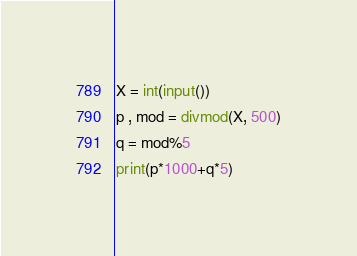<code> <loc_0><loc_0><loc_500><loc_500><_Python_>X = int(input())
p , mod = divmod(X, 500)
q = mod%5
print(p*1000+q*5)</code> 